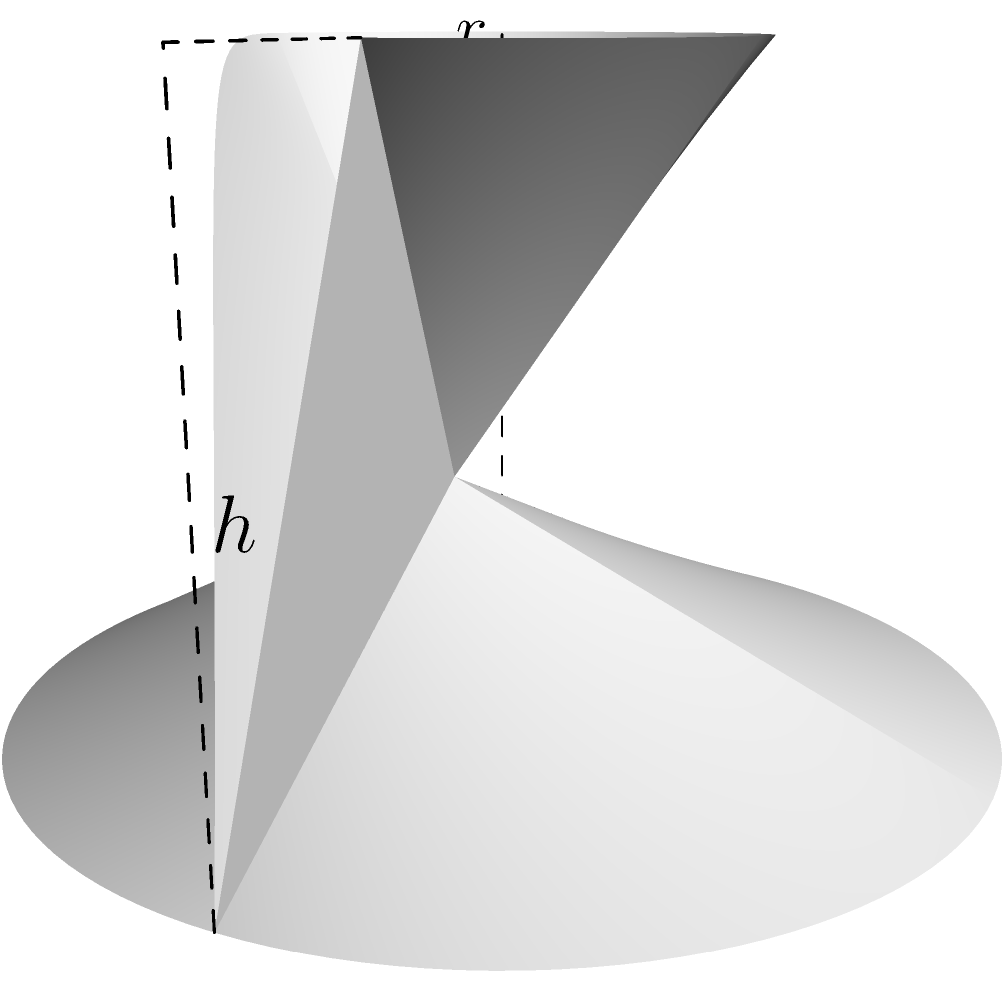As a web developer skilled in building custom RSS feed aggregators, you often work with data structures and algorithms. Consider a scenario where you need to calculate the volume of a container for storing aggregated data. The container is shaped like a truncated cone, with a bottom radius of 3 units, a top radius of 1.5 units, and a height of 4 units. Calculate the volume of this truncated cone using the formula:

$$ V = \frac{1}{3}\pi h(R^2 + r^2 + Rr) $$

Where $V$ is the volume, $h$ is the height, $R$ is the radius of the base, and $r$ is the radius of the top. To calculate the volume of the truncated cone, we'll use the given formula and substitute the known values:

1. Given values:
   $h = 4$ (height)
   $R = 3$ (bottom radius)
   $r = 1.5$ (top radius)

2. Substitute these values into the formula:
   $$ V = \frac{1}{3}\pi h(R^2 + r^2 + Rr) $$
   $$ V = \frac{1}{3}\pi \cdot 4(3^2 + 1.5^2 + 3 \cdot 1.5) $$

3. Simplify the expressions inside the parentheses:
   $$ V = \frac{1}{3}\pi \cdot 4(9 + 2.25 + 4.5) $$
   $$ V = \frac{1}{3}\pi \cdot 4(15.75) $$

4. Multiply the values:
   $$ V = \frac{4}{3}\pi \cdot 15.75 $$
   $$ V = 21\pi $$

5. For a more precise numerical value, we can use $\pi \approx 3.14159$:
   $$ V \approx 21 \cdot 3.14159 \approx 65.97339 \text{ cubic units} $$

Thus, the volume of the truncated cone is $21\pi$ or approximately 65.97339 cubic units.
Answer: $21\pi$ cubic units (or approximately 65.97339 cubic units) 